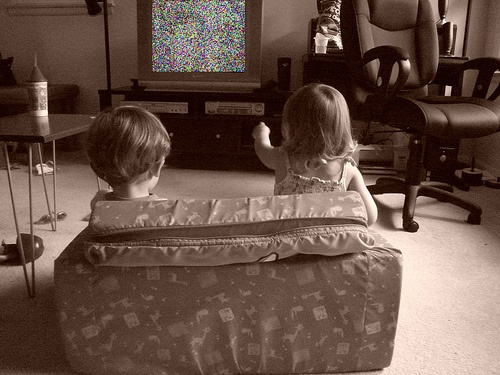Describe the objects in this image and their specific colors. I can see chair in maroon and gray tones, couch in maroon and gray tones, chair in maroon, black, and gray tones, tv in maroon, black, olive, and gray tones, and people in maroon, black, and gray tones in this image. 